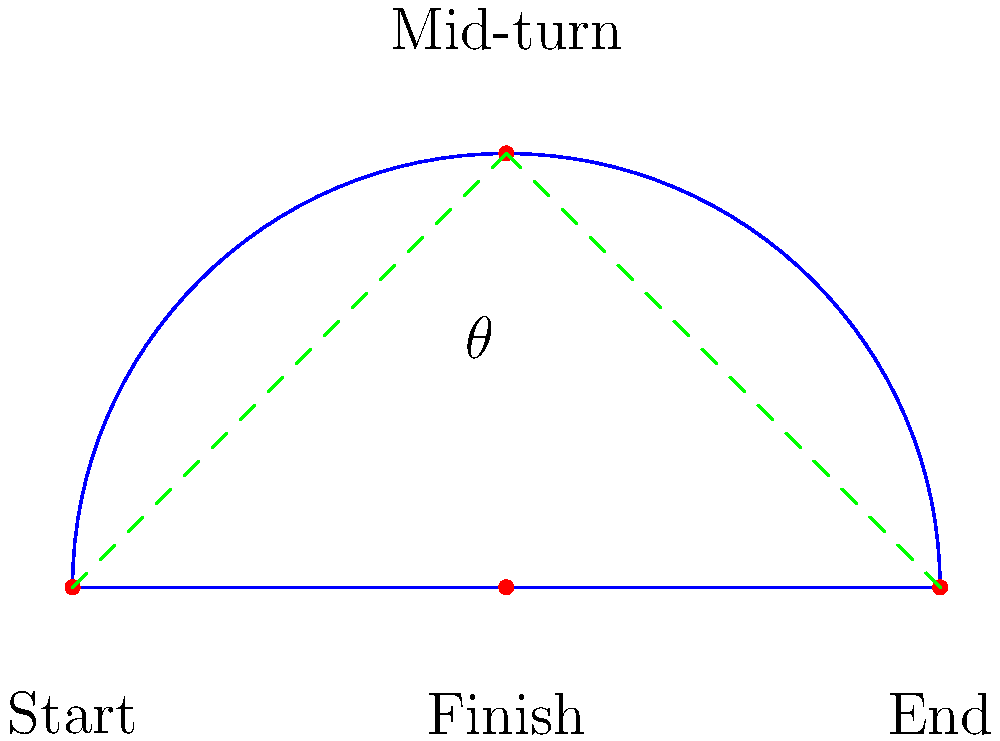In a smooth catwalk turn, the model's path forms an approximate isosceles triangle. If the turn covers a total distance of 200 cm and the angle $\theta$ at the apex of the turn is 120°, what is the straight-line distance between the start and end points of the turn? To solve this problem, let's follow these steps:

1. Recognize that the path forms an isosceles triangle, with two equal sides and the angle $\theta$ at the apex.

2. The total distance of 200 cm is divided equally between the two sides of the isosceles triangle. So each side is 100 cm.

3. We can use the law of cosines to find the third side (the straight-line distance we're looking for). Let's call this distance $d$.

4. The law of cosines states: $d^2 = a^2 + b^2 - 2ab \cos(\theta)$
   Where $a$ and $b$ are the equal sides of the isosceles triangle, and $\theta$ is the angle between them.

5. Substituting our known values:
   $d^2 = 100^2 + 100^2 - 2(100)(100) \cos(120°)$

6. Simplify:
   $d^2 = 10000 + 10000 - 20000 \cos(120°)$
   $d^2 = 20000 - 20000 (-0.5)$  (since $\cos(120°) = -0.5$)
   $d^2 = 20000 + 10000 = 30000$

7. Take the square root of both sides:
   $d = \sqrt{30000} = 10\sqrt{300} \approx 173.2$ cm

Therefore, the straight-line distance between the start and end points of the turn is approximately 173.2 cm.
Answer: $173.2$ cm 